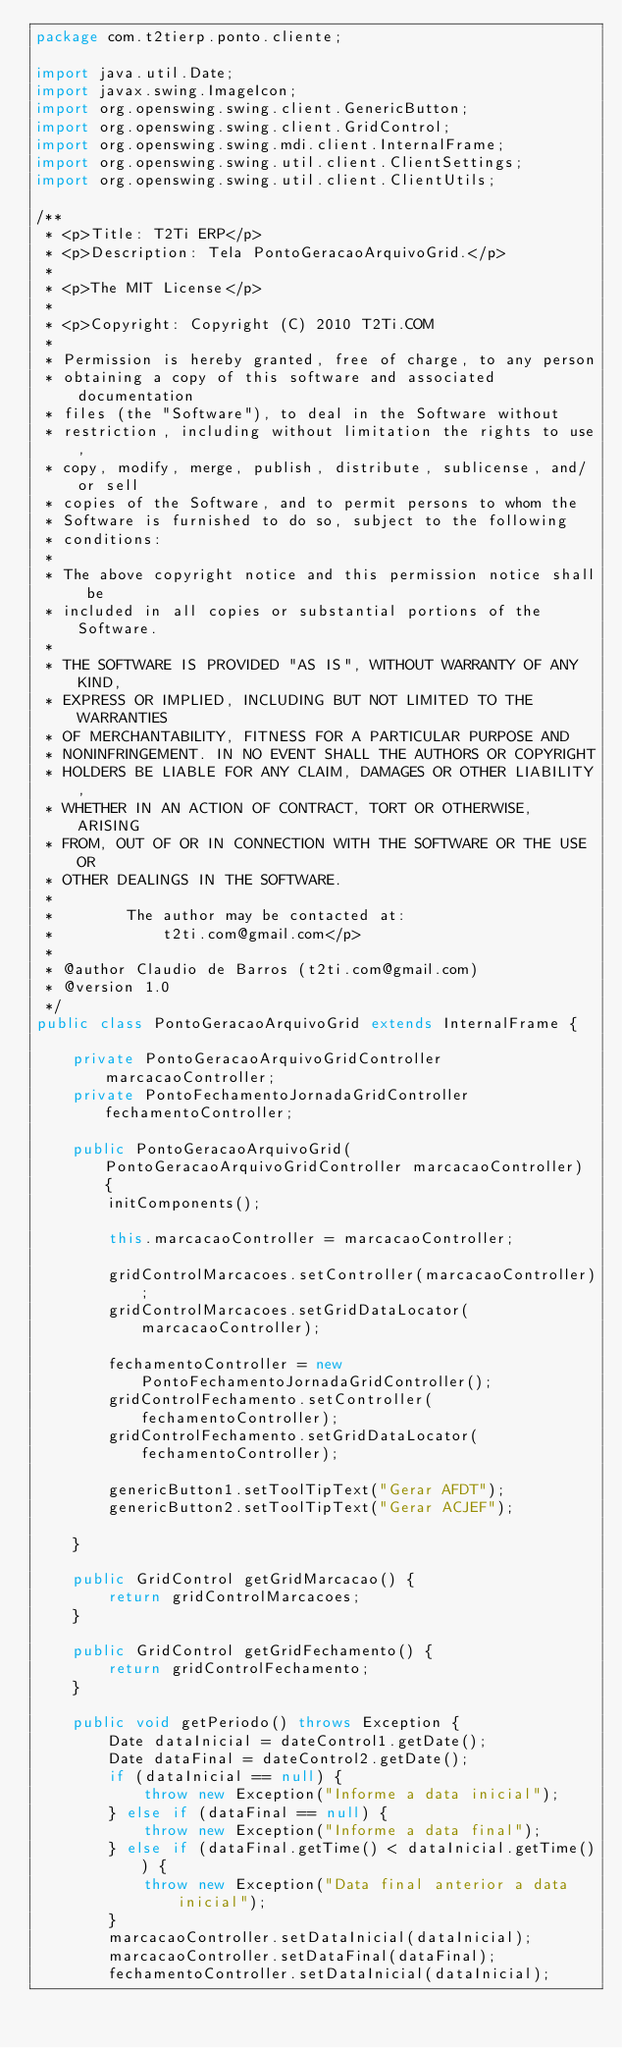Convert code to text. <code><loc_0><loc_0><loc_500><loc_500><_Java_>package com.t2tierp.ponto.cliente;

import java.util.Date;
import javax.swing.ImageIcon;
import org.openswing.swing.client.GenericButton;
import org.openswing.swing.client.GridControl;
import org.openswing.swing.mdi.client.InternalFrame;
import org.openswing.swing.util.client.ClientSettings;
import org.openswing.swing.util.client.ClientUtils;

/**
 * <p>Title: T2Ti ERP</p>
 * <p>Description: Tela PontoGeracaoArquivoGrid.</p>
 *
 * <p>The MIT License</p>
 *
 * <p>Copyright: Copyright (C) 2010 T2Ti.COM
 *
 * Permission is hereby granted, free of charge, to any person
 * obtaining a copy of this software and associated documentation
 * files (the "Software"), to deal in the Software without
 * restriction, including without limitation the rights to use,
 * copy, modify, merge, publish, distribute, sublicense, and/or sell
 * copies of the Software, and to permit persons to whom the
 * Software is furnished to do so, subject to the following
 * conditions:
 *
 * The above copyright notice and this permission notice shall be
 * included in all copies or substantial portions of the Software.
 *
 * THE SOFTWARE IS PROVIDED "AS IS", WITHOUT WARRANTY OF ANY KIND,
 * EXPRESS OR IMPLIED, INCLUDING BUT NOT LIMITED TO THE WARRANTIES
 * OF MERCHANTABILITY, FITNESS FOR A PARTICULAR PURPOSE AND
 * NONINFRINGEMENT. IN NO EVENT SHALL THE AUTHORS OR COPYRIGHT
 * HOLDERS BE LIABLE FOR ANY CLAIM, DAMAGES OR OTHER LIABILITY,
 * WHETHER IN AN ACTION OF CONTRACT, TORT OR OTHERWISE, ARISING
 * FROM, OUT OF OR IN CONNECTION WITH THE SOFTWARE OR THE USE OR
 * OTHER DEALINGS IN THE SOFTWARE.
 *
 *        The author may be contacted at:
 *            t2ti.com@gmail.com</p>
 *
 * @author Claudio de Barros (t2ti.com@gmail.com)
 * @version 1.0
 */
public class PontoGeracaoArquivoGrid extends InternalFrame {

    private PontoGeracaoArquivoGridController marcacaoController;
    private PontoFechamentoJornadaGridController fechamentoController;

    public PontoGeracaoArquivoGrid(PontoGeracaoArquivoGridController marcacaoController) {
        initComponents();

        this.marcacaoController = marcacaoController;

        gridControlMarcacoes.setController(marcacaoController);
        gridControlMarcacoes.setGridDataLocator(marcacaoController);

        fechamentoController = new PontoFechamentoJornadaGridController();
        gridControlFechamento.setController(fechamentoController);
        gridControlFechamento.setGridDataLocator(fechamentoController);

        genericButton1.setToolTipText("Gerar AFDT");
        genericButton2.setToolTipText("Gerar ACJEF");

    }

    public GridControl getGridMarcacao() {
        return gridControlMarcacoes;
    }

    public GridControl getGridFechamento() {
        return gridControlFechamento;
    }

    public void getPeriodo() throws Exception {
        Date dataInicial = dateControl1.getDate();
        Date dataFinal = dateControl2.getDate();
        if (dataInicial == null) {
            throw new Exception("Informe a data inicial");
        } else if (dataFinal == null) {
            throw new Exception("Informe a data final");
        } else if (dataFinal.getTime() < dataInicial.getTime()) {
            throw new Exception("Data final anterior a data inicial");
        }
        marcacaoController.setDataInicial(dataInicial);
        marcacaoController.setDataFinal(dataFinal);
        fechamentoController.setDataInicial(dataInicial);</code> 